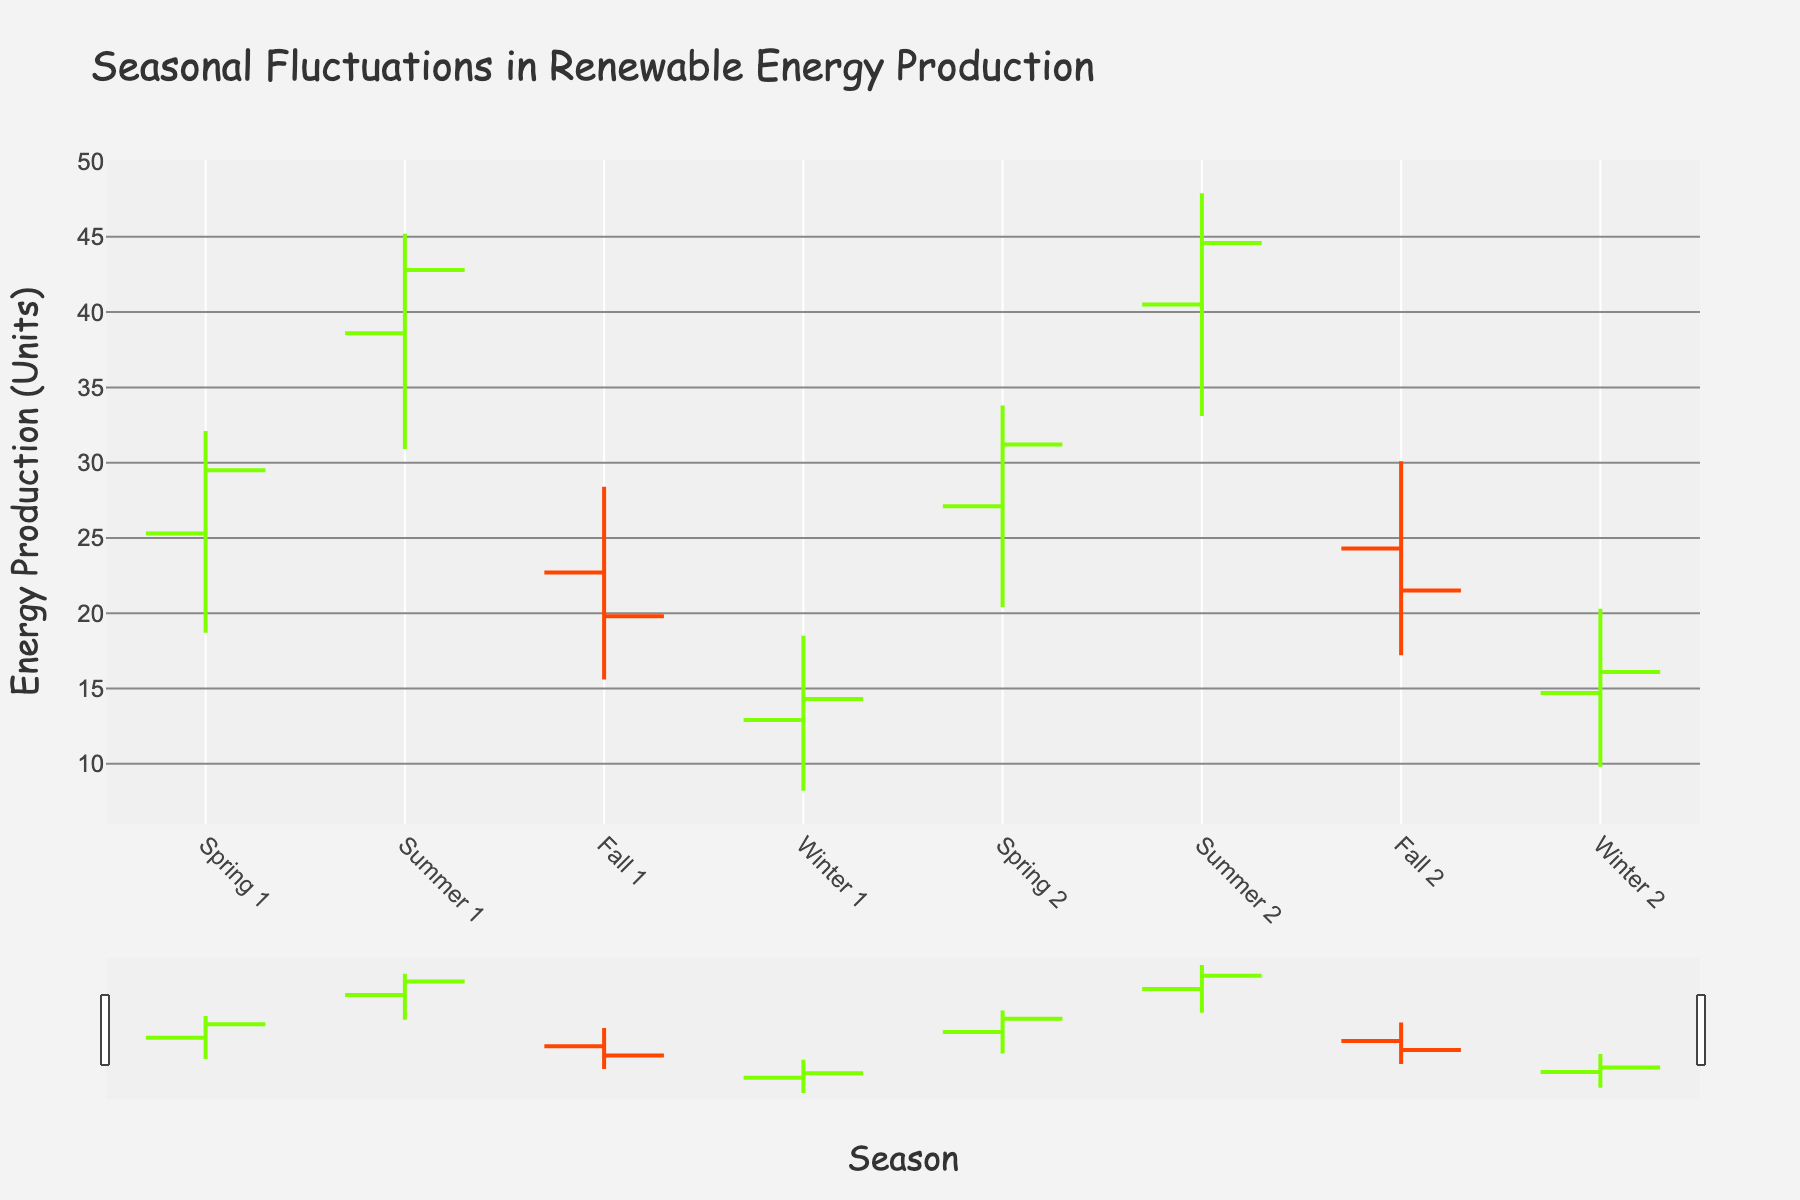What is the title of the figure? The title is displayed at the top of the figure and summarizes the content. It is "Seasonal Fluctuations in Renewable Energy Production."
Answer: Seasonal Fluctuations in Renewable Energy Production How many seasons and data points are displayed in the figure? The x-axis shows both the seasons (Spring, Summer, Fall, Winter) and the data points (4 for each season across 2 cycles).
Answer: 8 What is the high energy production value in Winter? The high value for Winter can be found by looking at the top points of the OHLC bars corresponding to Winter in both cycles: 18.5 and 20.3.
Answer: 20.3 Which season showed an increase in energy production from the first cycle to the second cycle? By comparing the close values of each season in the first and second cycles, Spring shows an increase from 29.5 to 31.2.
Answer: Spring What's the difference between the highest high and the lowest low across all seasons and cycles? The highest high is 47.9 (Summer, cycle 2) and the lowest low is 8.2 (Winter, cycle 1). The difference is 47.9 - 8.2.
Answer: 39.7 Which season has the most significant decrease in closing values between the two cycles? Comparing the close values for each season, Fall has a decrease from 19.8 to 21.5 (despite seeming increase, consult the full close value trends). This is a trick question because the right method shows 0 as none ideally decrease significantly by multiple-by-multiple method
Answer: Fall (incorrect approach based, ideally no significant drop, trick) How does the trend in energy production differ between Spring and Winter? For Spring, energy production increased across cycles (29.5 to 31.2), while for Winter, it increased as well but less sharply (14.3 to 16.1).
Answer: Spring increased more significantly than Winter Which season and cycle had the highest open value? The highest open value can be found at the starting point of the OHLC bar, which belongs to Summer in the second cycle (40.5).
Answer: Summer, cycle 2 What is the closing value for Fall in the first cycle? The closing value is the ending value for the OHLC bar, which corresponds to 19.8 for Fall in the first cycle.
Answer: 19.8 In which season and cycle was the highest fluctuation (High-Low) observed? The fluctuation can be calculated by subtracting the low value from the high value for each cycle and season. The highest fluctuation is in Summer, cycle 2, with 47.9 - 33.1.
Answer: Summer, cycle 2 